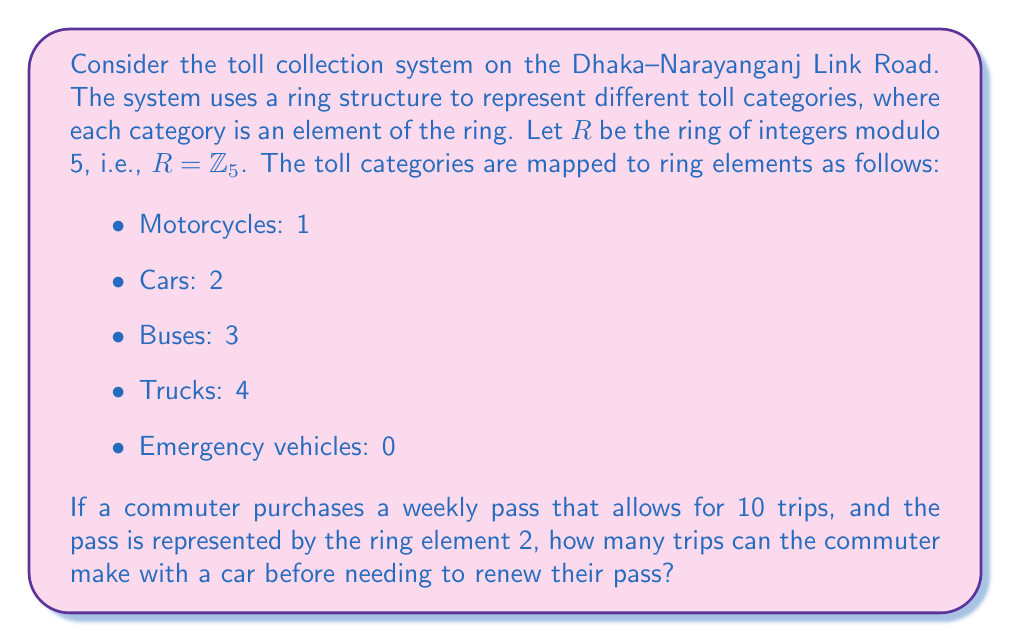Could you help me with this problem? To solve this problem, we need to use the properties of ring theory and modular arithmetic:

1) In the ring $R = \mathbb{Z}_5$, addition is performed modulo 5.

2) The weekly pass is represented by the ring element 2, which corresponds to cars.

3) Each trip with a car will subtract 2 from the pass value.

4) We need to find how many times we can subtract 2 from 10 (modulo 5) before reaching 0.

Let's perform the calculations:

$$10 \equiv 0 \pmod{5}$$

Starting from 0:
- Trip 1: $0 - 2 \equiv 3 \pmod{5}$
- Trip 2: $3 - 2 \equiv 1 \pmod{5}$
- Trip 3: $1 - 2 \equiv 4 \pmod{5}$
- Trip 4: $4 - 2 \equiv 2 \pmod{5}$
- Trip 5: $2 - 2 \equiv 0 \pmod{5}$

After 5 trips, we're back to 0, which means the pass has been fully used.
Answer: The commuter can make 5 trips with a car before needing to renew their pass. 